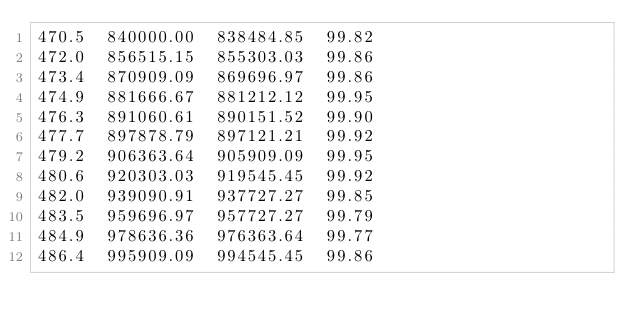Convert code to text. <code><loc_0><loc_0><loc_500><loc_500><_SML_>470.5  840000.00  838484.85  99.82
472.0  856515.15  855303.03  99.86
473.4  870909.09  869696.97  99.86
474.9  881666.67  881212.12  99.95
476.3  891060.61  890151.52  99.90
477.7  897878.79  897121.21  99.92
479.2  906363.64  905909.09  99.95
480.6  920303.03  919545.45  99.92
482.0  939090.91  937727.27  99.85
483.5  959696.97  957727.27  99.79
484.9  978636.36  976363.64  99.77
486.4  995909.09  994545.45  99.86</code> 